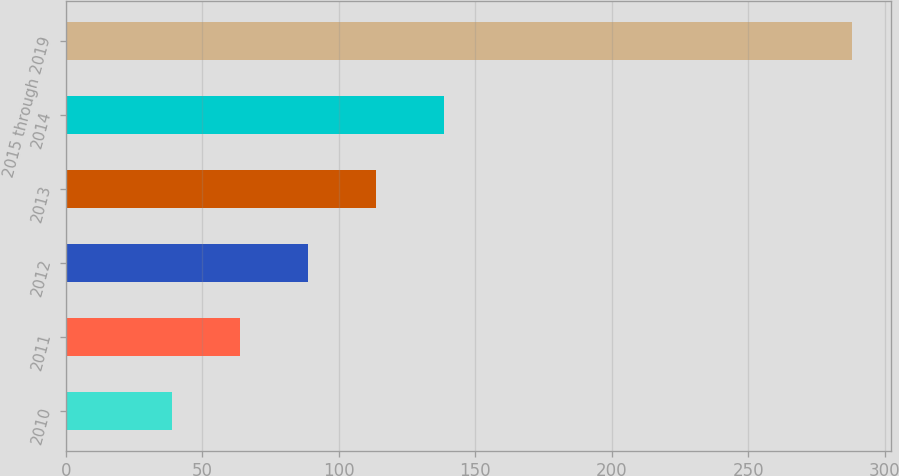<chart> <loc_0><loc_0><loc_500><loc_500><bar_chart><fcel>2010<fcel>2011<fcel>2012<fcel>2013<fcel>2014<fcel>2015 through 2019<nl><fcel>39<fcel>63.9<fcel>88.8<fcel>113.7<fcel>138.6<fcel>288<nl></chart> 